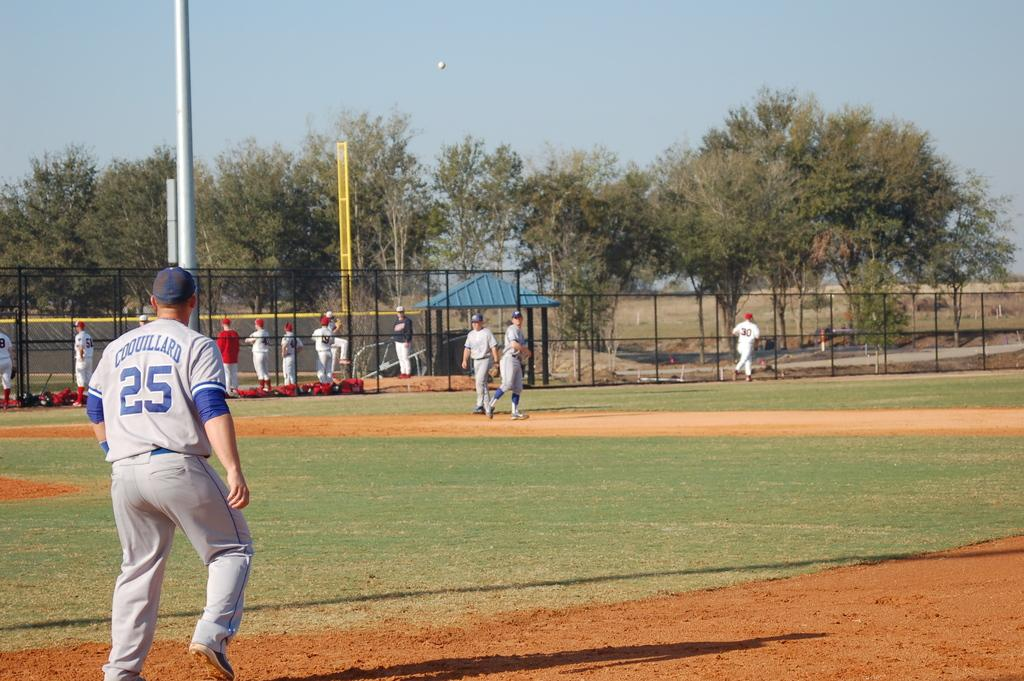<image>
Render a clear and concise summary of the photo. player number 25, coouillard looking toward other players near fencing 